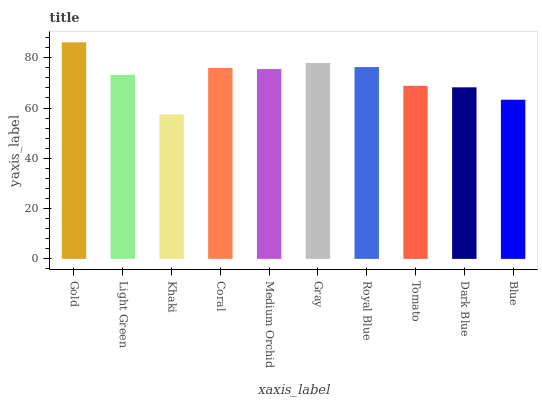Is Khaki the minimum?
Answer yes or no. Yes. Is Gold the maximum?
Answer yes or no. Yes. Is Light Green the minimum?
Answer yes or no. No. Is Light Green the maximum?
Answer yes or no. No. Is Gold greater than Light Green?
Answer yes or no. Yes. Is Light Green less than Gold?
Answer yes or no. Yes. Is Light Green greater than Gold?
Answer yes or no. No. Is Gold less than Light Green?
Answer yes or no. No. Is Medium Orchid the high median?
Answer yes or no. Yes. Is Light Green the low median?
Answer yes or no. Yes. Is Blue the high median?
Answer yes or no. No. Is Royal Blue the low median?
Answer yes or no. No. 